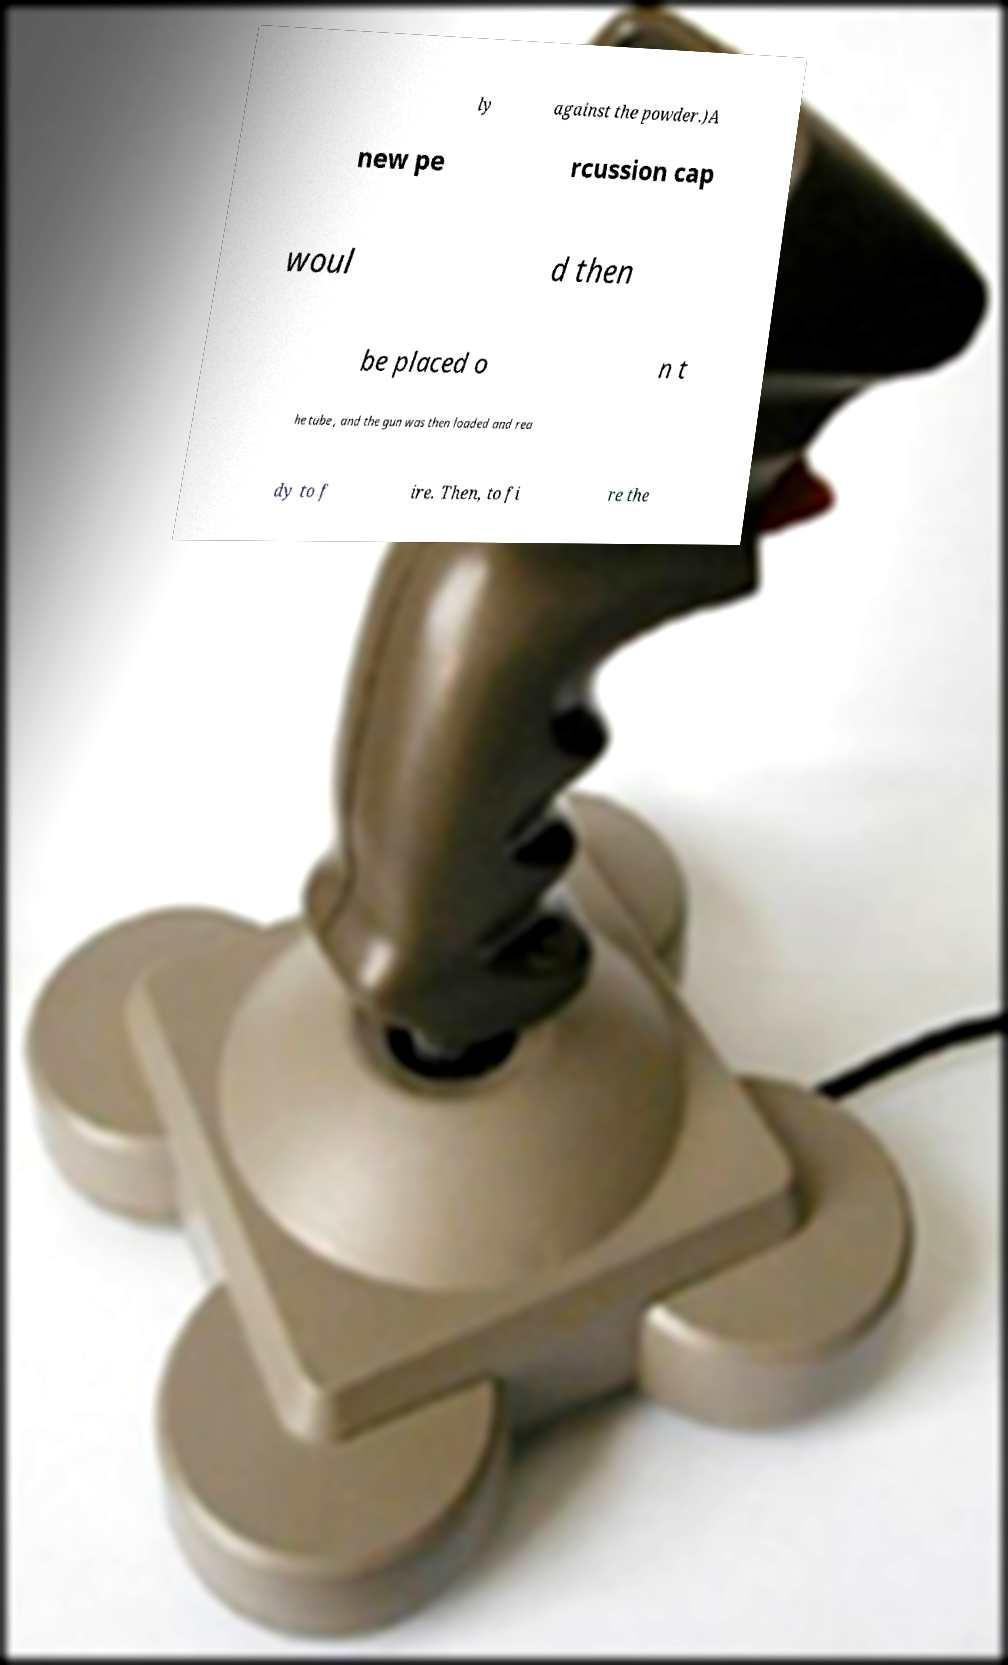Could you assist in decoding the text presented in this image and type it out clearly? ly against the powder.)A new pe rcussion cap woul d then be placed o n t he tube , and the gun was then loaded and rea dy to f ire. Then, to fi re the 